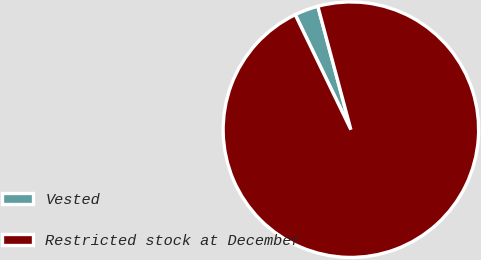Convert chart to OTSL. <chart><loc_0><loc_0><loc_500><loc_500><pie_chart><fcel>Vested<fcel>Restricted stock at December<nl><fcel>3.01%<fcel>96.99%<nl></chart> 